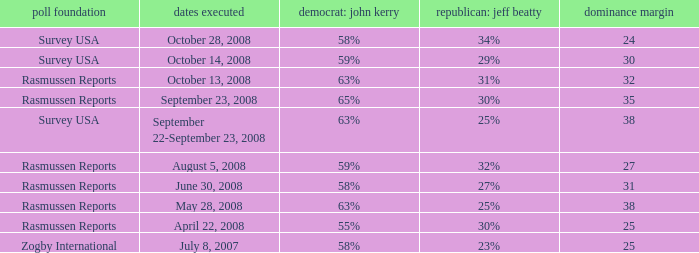Who is the poll source that has Republican: Jeff Beatty behind at 27%? Rasmussen Reports. 